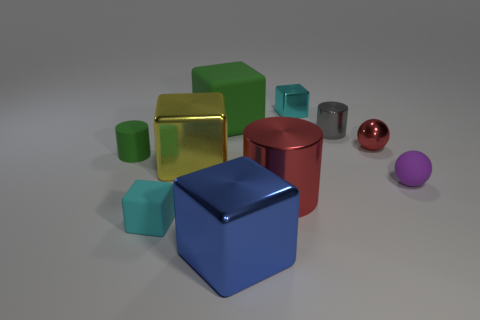Subtract all yellow blocks. How many blocks are left? 4 Subtract all tiny rubber cubes. How many cubes are left? 4 Subtract all purple cubes. Subtract all gray spheres. How many cubes are left? 5 Subtract all balls. How many objects are left? 8 Subtract all green matte spheres. Subtract all gray metal cylinders. How many objects are left? 9 Add 4 small gray shiny things. How many small gray shiny things are left? 5 Add 3 big matte blocks. How many big matte blocks exist? 4 Subtract 0 brown blocks. How many objects are left? 10 